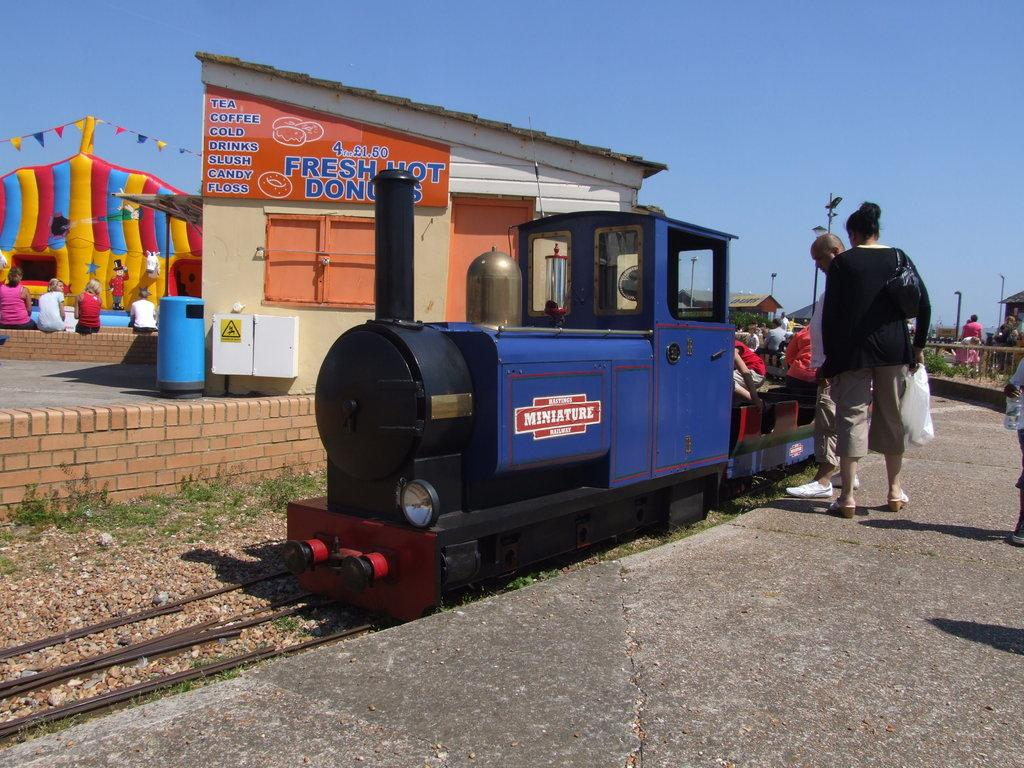What is the main subject of the image? The main subject of the image is a train on the track. Can you describe the people visible in the image? The facts do not specify the appearance or actions of the people in the image. What is the purpose of the bin in the image? The facts do not specify the purpose of the bin in the image. What are the boxes used for in the image? The facts do not specify the purpose or contents of the boxes in the image. What are the poles supporting in the image? The facts do not specify what the poles are supporting in the image. What type of fence is present in the image? The facts do not specify the type of fence in the image. What kind of plants are present in the image? The facts do not specify the type of plants in the image. What are the sheds used for in the image? The facts do not specify the purpose or contents of the sheds in the image. What is written on the board in the image? The facts do not specify what is written on the board in the image. What do the flags represent in the image? The facts do not specify the meaning or purpose of the flags in the image. What is the unspecified object in the image? The facts do not provide any information about the unspecified object in the image. What is the color of the sky in the background of the image? The facts do not specify the color of the sky in the background of the image. What type of marble is being used to write on the paper in the image? There is no marble or paper present in the image. 